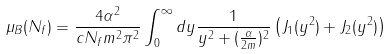Convert formula to latex. <formula><loc_0><loc_0><loc_500><loc_500>\mu _ { B } ( N _ { f } ) = \frac { 4 \alpha ^ { 2 } } { c N _ { f } m ^ { 2 } \pi ^ { 2 } } \int _ { 0 } ^ { \infty } d y \frac { 1 } { y ^ { 2 } + ( \frac { \alpha } { 2 m } ) ^ { 2 } } \left ( J _ { 1 } ( y ^ { 2 } ) + J _ { 2 } ( y ^ { 2 } ) \right )</formula> 